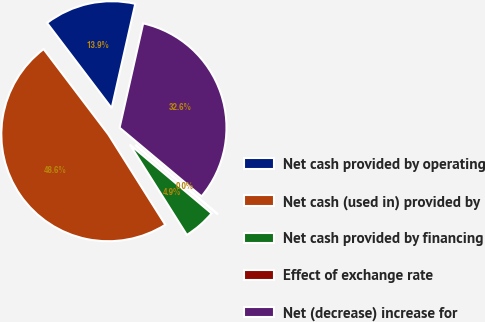<chart> <loc_0><loc_0><loc_500><loc_500><pie_chart><fcel>Net cash provided by operating<fcel>Net cash (used in) provided by<fcel>Net cash provided by financing<fcel>Effect of exchange rate<fcel>Net (decrease) increase for<nl><fcel>13.87%<fcel>48.63%<fcel>4.9%<fcel>0.04%<fcel>32.56%<nl></chart> 